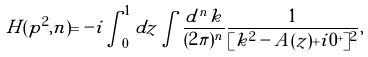Convert formula to latex. <formula><loc_0><loc_0><loc_500><loc_500>H ( p ^ { 2 } , n ) = - i \int _ { 0 } ^ { 1 } d z \int \frac { d ^ { n } k } { ( 2 \pi ) ^ { n } } \frac { 1 } { [ k ^ { 2 } - A ( z ) + i 0 ^ { + } ] ^ { 2 } } ,</formula> 